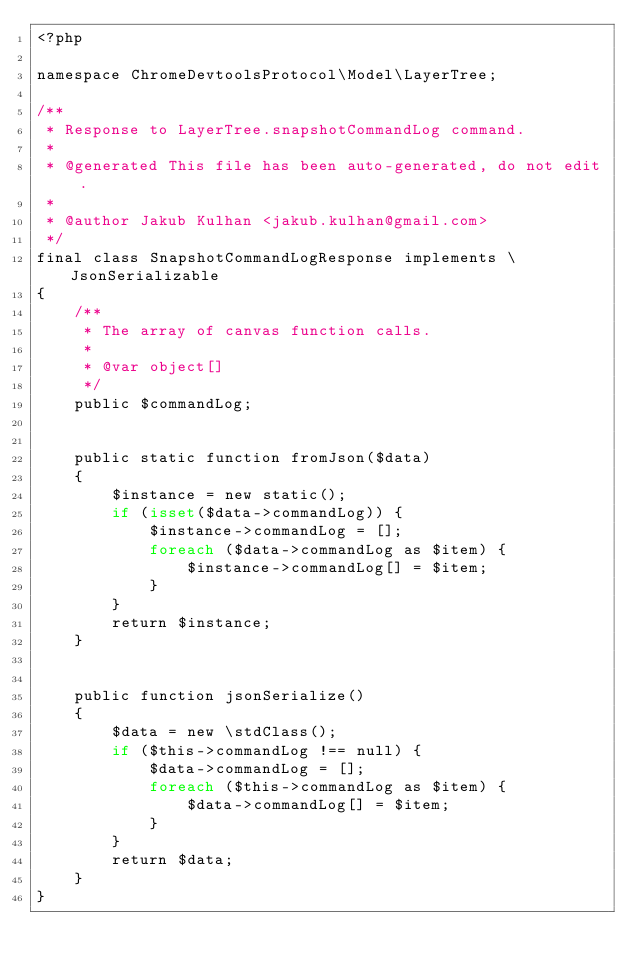<code> <loc_0><loc_0><loc_500><loc_500><_PHP_><?php

namespace ChromeDevtoolsProtocol\Model\LayerTree;

/**
 * Response to LayerTree.snapshotCommandLog command.
 *
 * @generated This file has been auto-generated, do not edit.
 *
 * @author Jakub Kulhan <jakub.kulhan@gmail.com>
 */
final class SnapshotCommandLogResponse implements \JsonSerializable
{
	/**
	 * The array of canvas function calls.
	 *
	 * @var object[]
	 */
	public $commandLog;


	public static function fromJson($data)
	{
		$instance = new static();
		if (isset($data->commandLog)) {
			$instance->commandLog = [];
			foreach ($data->commandLog as $item) {
				$instance->commandLog[] = $item;
			}
		}
		return $instance;
	}


	public function jsonSerialize()
	{
		$data = new \stdClass();
		if ($this->commandLog !== null) {
			$data->commandLog = [];
			foreach ($this->commandLog as $item) {
				$data->commandLog[] = $item;
			}
		}
		return $data;
	}
}
</code> 